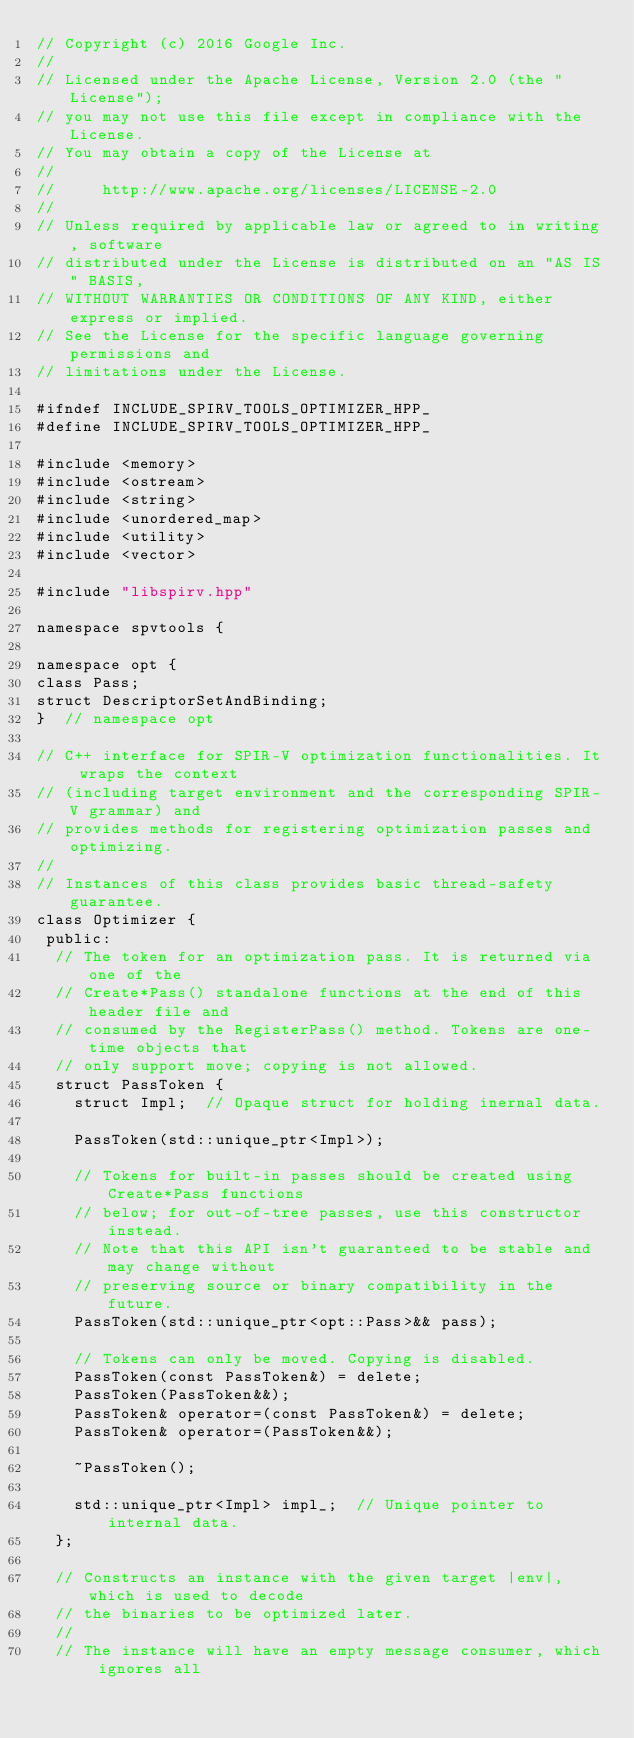Convert code to text. <code><loc_0><loc_0><loc_500><loc_500><_C++_>// Copyright (c) 2016 Google Inc.
//
// Licensed under the Apache License, Version 2.0 (the "License");
// you may not use this file except in compliance with the License.
// You may obtain a copy of the License at
//
//     http://www.apache.org/licenses/LICENSE-2.0
//
// Unless required by applicable law or agreed to in writing, software
// distributed under the License is distributed on an "AS IS" BASIS,
// WITHOUT WARRANTIES OR CONDITIONS OF ANY KIND, either express or implied.
// See the License for the specific language governing permissions and
// limitations under the License.

#ifndef INCLUDE_SPIRV_TOOLS_OPTIMIZER_HPP_
#define INCLUDE_SPIRV_TOOLS_OPTIMIZER_HPP_

#include <memory>
#include <ostream>
#include <string>
#include <unordered_map>
#include <utility>
#include <vector>

#include "libspirv.hpp"

namespace spvtools {

namespace opt {
class Pass;
struct DescriptorSetAndBinding;
}  // namespace opt

// C++ interface for SPIR-V optimization functionalities. It wraps the context
// (including target environment and the corresponding SPIR-V grammar) and
// provides methods for registering optimization passes and optimizing.
//
// Instances of this class provides basic thread-safety guarantee.
class Optimizer {
 public:
  // The token for an optimization pass. It is returned via one of the
  // Create*Pass() standalone functions at the end of this header file and
  // consumed by the RegisterPass() method. Tokens are one-time objects that
  // only support move; copying is not allowed.
  struct PassToken {
    struct Impl;  // Opaque struct for holding inernal data.

    PassToken(std::unique_ptr<Impl>);

    // Tokens for built-in passes should be created using Create*Pass functions
    // below; for out-of-tree passes, use this constructor instead.
    // Note that this API isn't guaranteed to be stable and may change without
    // preserving source or binary compatibility in the future.
    PassToken(std::unique_ptr<opt::Pass>&& pass);

    // Tokens can only be moved. Copying is disabled.
    PassToken(const PassToken&) = delete;
    PassToken(PassToken&&);
    PassToken& operator=(const PassToken&) = delete;
    PassToken& operator=(PassToken&&);

    ~PassToken();

    std::unique_ptr<Impl> impl_;  // Unique pointer to internal data.
  };

  // Constructs an instance with the given target |env|, which is used to decode
  // the binaries to be optimized later.
  //
  // The instance will have an empty message consumer, which ignores all</code> 